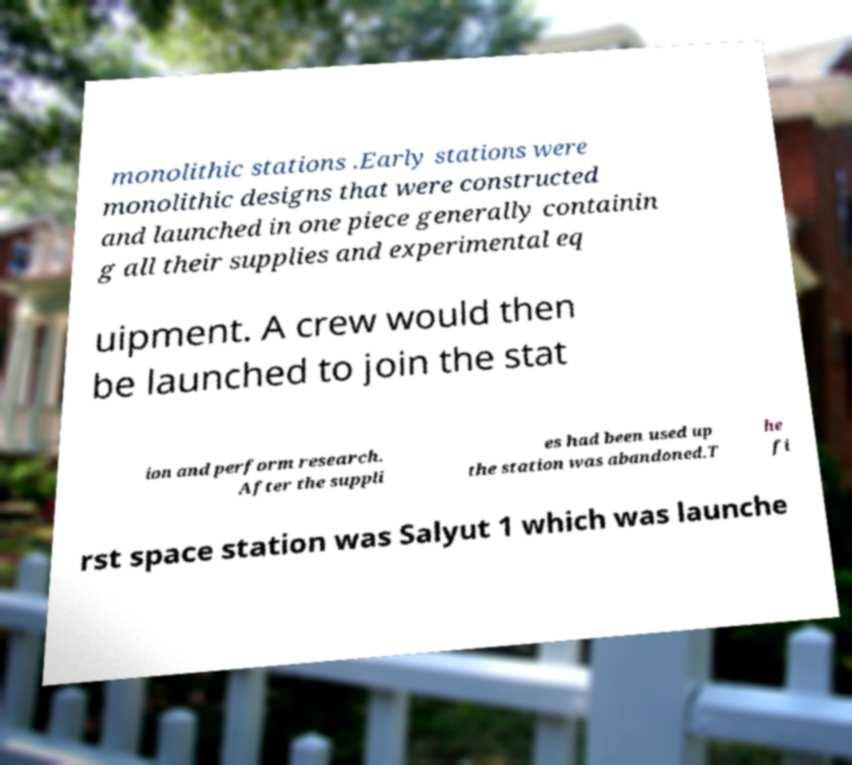Could you extract and type out the text from this image? monolithic stations .Early stations were monolithic designs that were constructed and launched in one piece generally containin g all their supplies and experimental eq uipment. A crew would then be launched to join the stat ion and perform research. After the suppli es had been used up the station was abandoned.T he fi rst space station was Salyut 1 which was launche 